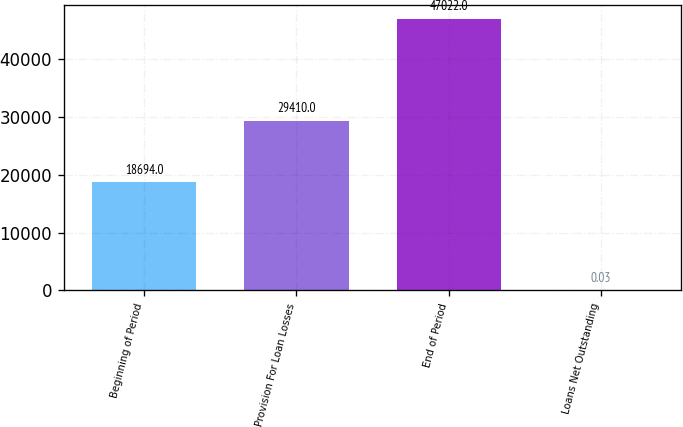Convert chart to OTSL. <chart><loc_0><loc_0><loc_500><loc_500><bar_chart><fcel>Beginning of Period<fcel>Provision For Loan Losses<fcel>End of Period<fcel>Loans Net Outstanding<nl><fcel>18694<fcel>29410<fcel>47022<fcel>0.03<nl></chart> 